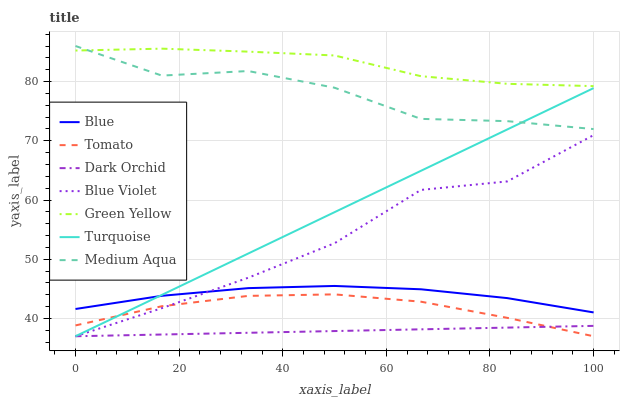Does Dark Orchid have the minimum area under the curve?
Answer yes or no. Yes. Does Green Yellow have the maximum area under the curve?
Answer yes or no. Yes. Does Tomato have the minimum area under the curve?
Answer yes or no. No. Does Tomato have the maximum area under the curve?
Answer yes or no. No. Is Turquoise the smoothest?
Answer yes or no. Yes. Is Blue Violet the roughest?
Answer yes or no. Yes. Is Tomato the smoothest?
Answer yes or no. No. Is Tomato the roughest?
Answer yes or no. No. Does Tomato have the lowest value?
Answer yes or no. Yes. Does Medium Aqua have the lowest value?
Answer yes or no. No. Does Medium Aqua have the highest value?
Answer yes or no. Yes. Does Tomato have the highest value?
Answer yes or no. No. Is Dark Orchid less than Medium Aqua?
Answer yes or no. Yes. Is Blue greater than Tomato?
Answer yes or no. Yes. Does Turquoise intersect Tomato?
Answer yes or no. Yes. Is Turquoise less than Tomato?
Answer yes or no. No. Is Turquoise greater than Tomato?
Answer yes or no. No. Does Dark Orchid intersect Medium Aqua?
Answer yes or no. No. 